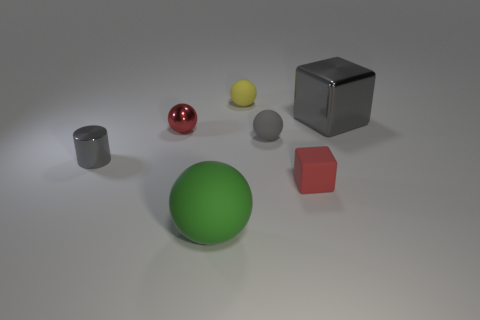Do the shiny cylinder and the shiny block to the right of the yellow rubber sphere have the same color?
Keep it short and to the point. Yes. There is a object that is behind the tiny metallic ball and on the right side of the gray rubber object; how big is it?
Make the answer very short. Large. How big is the rubber sphere that is in front of the small cylinder that is in front of the small ball on the right side of the tiny yellow rubber thing?
Offer a terse response. Large. There is a metal thing that is the same color as the tiny cylinder; what size is it?
Give a very brief answer. Large. What number of objects are either tiny gray matte objects or large metal blocks?
Provide a short and direct response. 2. There is a object that is on the right side of the gray rubber thing and behind the metal cylinder; what shape is it?
Ensure brevity in your answer.  Cube. Does the large matte thing have the same shape as the large thing that is behind the big green matte object?
Provide a short and direct response. No. Are there any small yellow objects left of the big rubber thing?
Offer a terse response. No. What material is the ball that is the same color as the large cube?
Make the answer very short. Rubber. How many cylinders are either large green rubber things or large gray objects?
Your answer should be very brief. 0. 